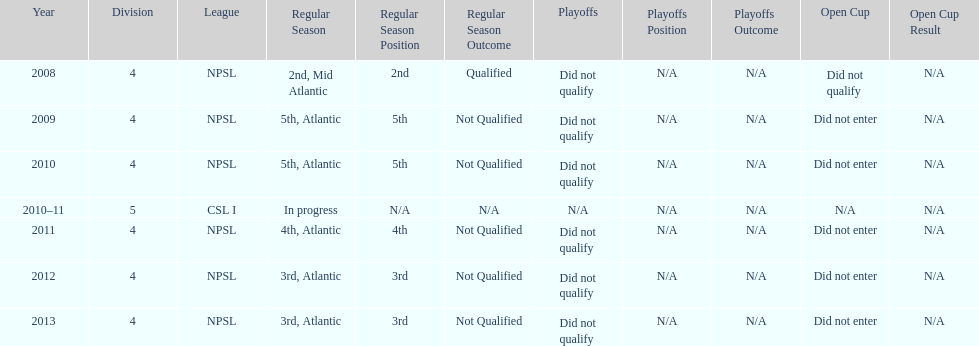Apart from npsl, which league has ny men's soccer team participated in? CSL I. 